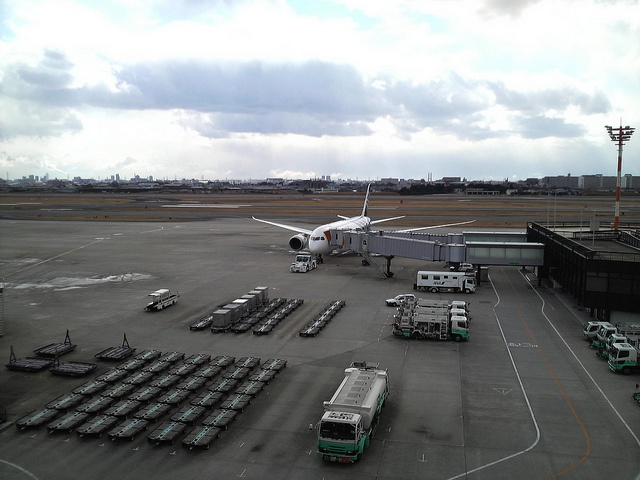Describe the objects in this image and their specific colors. I can see truck in lightblue, black, gray, darkgray, and darkgreen tones, airplane in lightblue, gray, lightgray, darkgray, and black tones, truck in lightblue, black, gray, darkgray, and teal tones, truck in lightblue, black, gray, and darkgray tones, and truck in lightblue, black, gray, darkgray, and darkgreen tones in this image. 